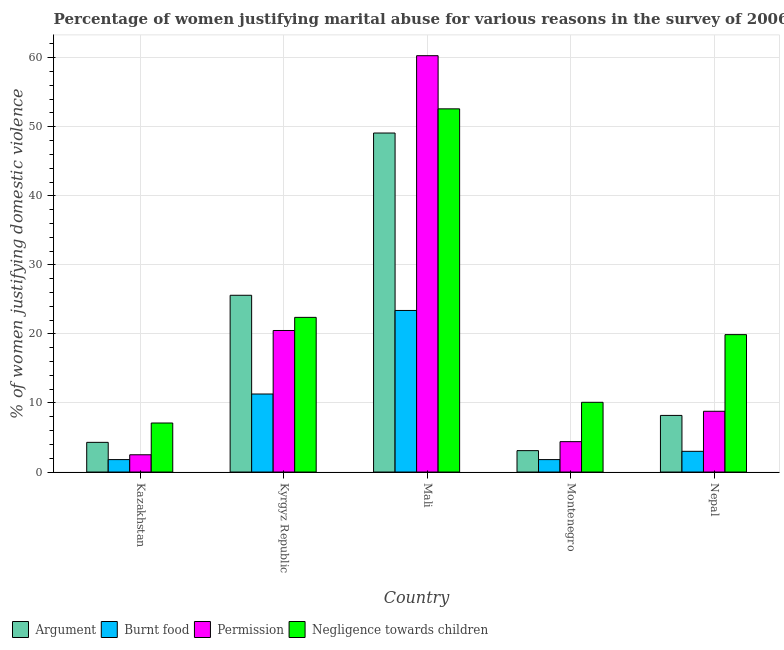How many groups of bars are there?
Give a very brief answer. 5. Are the number of bars per tick equal to the number of legend labels?
Keep it short and to the point. Yes. Are the number of bars on each tick of the X-axis equal?
Offer a terse response. Yes. What is the label of the 2nd group of bars from the left?
Make the answer very short. Kyrgyz Republic. What is the percentage of women justifying abuse for going without permission in Kyrgyz Republic?
Your answer should be compact. 20.5. Across all countries, what is the maximum percentage of women justifying abuse for burning food?
Offer a terse response. 23.4. Across all countries, what is the minimum percentage of women justifying abuse for showing negligence towards children?
Offer a very short reply. 7.1. In which country was the percentage of women justifying abuse for burning food maximum?
Offer a terse response. Mali. In which country was the percentage of women justifying abuse for burning food minimum?
Your response must be concise. Kazakhstan. What is the total percentage of women justifying abuse for showing negligence towards children in the graph?
Give a very brief answer. 112.1. What is the difference between the percentage of women justifying abuse for showing negligence towards children in Mali and that in Montenegro?
Offer a terse response. 42.5. What is the average percentage of women justifying abuse for burning food per country?
Make the answer very short. 8.26. What is the difference between the percentage of women justifying abuse for burning food and percentage of women justifying abuse in the case of an argument in Kazakhstan?
Ensure brevity in your answer.  -2.5. In how many countries, is the percentage of women justifying abuse in the case of an argument greater than 58 %?
Provide a succinct answer. 0. What is the ratio of the percentage of women justifying abuse for going without permission in Kyrgyz Republic to that in Nepal?
Make the answer very short. 2.33. Is the difference between the percentage of women justifying abuse for burning food in Kazakhstan and Mali greater than the difference between the percentage of women justifying abuse for going without permission in Kazakhstan and Mali?
Keep it short and to the point. Yes. What is the difference between the highest and the second highest percentage of women justifying abuse for going without permission?
Provide a short and direct response. 39.8. What is the difference between the highest and the lowest percentage of women justifying abuse for going without permission?
Your answer should be compact. 57.8. In how many countries, is the percentage of women justifying abuse for showing negligence towards children greater than the average percentage of women justifying abuse for showing negligence towards children taken over all countries?
Provide a short and direct response. 1. Is the sum of the percentage of women justifying abuse for going without permission in Kazakhstan and Kyrgyz Republic greater than the maximum percentage of women justifying abuse in the case of an argument across all countries?
Make the answer very short. No. Is it the case that in every country, the sum of the percentage of women justifying abuse in the case of an argument and percentage of women justifying abuse for going without permission is greater than the sum of percentage of women justifying abuse for showing negligence towards children and percentage of women justifying abuse for burning food?
Provide a short and direct response. No. What does the 2nd bar from the left in Mali represents?
Your answer should be compact. Burnt food. What does the 1st bar from the right in Montenegro represents?
Your response must be concise. Negligence towards children. Is it the case that in every country, the sum of the percentage of women justifying abuse in the case of an argument and percentage of women justifying abuse for burning food is greater than the percentage of women justifying abuse for going without permission?
Give a very brief answer. Yes. How many bars are there?
Your answer should be compact. 20. What is the difference between two consecutive major ticks on the Y-axis?
Ensure brevity in your answer.  10. How are the legend labels stacked?
Provide a short and direct response. Horizontal. What is the title of the graph?
Ensure brevity in your answer.  Percentage of women justifying marital abuse for various reasons in the survey of 2006. Does "Rule based governance" appear as one of the legend labels in the graph?
Offer a very short reply. No. What is the label or title of the Y-axis?
Provide a succinct answer. % of women justifying domestic violence. What is the % of women justifying domestic violence in Argument in Kazakhstan?
Give a very brief answer. 4.3. What is the % of women justifying domestic violence in Permission in Kazakhstan?
Make the answer very short. 2.5. What is the % of women justifying domestic violence in Argument in Kyrgyz Republic?
Provide a short and direct response. 25.6. What is the % of women justifying domestic violence of Burnt food in Kyrgyz Republic?
Provide a succinct answer. 11.3. What is the % of women justifying domestic violence of Negligence towards children in Kyrgyz Republic?
Provide a succinct answer. 22.4. What is the % of women justifying domestic violence in Argument in Mali?
Offer a very short reply. 49.1. What is the % of women justifying domestic violence in Burnt food in Mali?
Ensure brevity in your answer.  23.4. What is the % of women justifying domestic violence of Permission in Mali?
Provide a succinct answer. 60.3. What is the % of women justifying domestic violence of Negligence towards children in Mali?
Your response must be concise. 52.6. What is the % of women justifying domestic violence in Permission in Montenegro?
Your response must be concise. 4.4. What is the % of women justifying domestic violence of Negligence towards children in Montenegro?
Offer a terse response. 10.1. What is the % of women justifying domestic violence of Argument in Nepal?
Your answer should be very brief. 8.2. What is the % of women justifying domestic violence of Permission in Nepal?
Your answer should be very brief. 8.8. What is the % of women justifying domestic violence of Negligence towards children in Nepal?
Your answer should be compact. 19.9. Across all countries, what is the maximum % of women justifying domestic violence in Argument?
Your response must be concise. 49.1. Across all countries, what is the maximum % of women justifying domestic violence of Burnt food?
Your response must be concise. 23.4. Across all countries, what is the maximum % of women justifying domestic violence of Permission?
Make the answer very short. 60.3. Across all countries, what is the maximum % of women justifying domestic violence of Negligence towards children?
Provide a succinct answer. 52.6. Across all countries, what is the minimum % of women justifying domestic violence of Burnt food?
Offer a terse response. 1.8. What is the total % of women justifying domestic violence of Argument in the graph?
Provide a succinct answer. 90.3. What is the total % of women justifying domestic violence of Burnt food in the graph?
Your response must be concise. 41.3. What is the total % of women justifying domestic violence in Permission in the graph?
Give a very brief answer. 96.5. What is the total % of women justifying domestic violence in Negligence towards children in the graph?
Your answer should be compact. 112.1. What is the difference between the % of women justifying domestic violence of Argument in Kazakhstan and that in Kyrgyz Republic?
Provide a short and direct response. -21.3. What is the difference between the % of women justifying domestic violence of Burnt food in Kazakhstan and that in Kyrgyz Republic?
Offer a terse response. -9.5. What is the difference between the % of women justifying domestic violence of Permission in Kazakhstan and that in Kyrgyz Republic?
Keep it short and to the point. -18. What is the difference between the % of women justifying domestic violence in Negligence towards children in Kazakhstan and that in Kyrgyz Republic?
Give a very brief answer. -15.3. What is the difference between the % of women justifying domestic violence in Argument in Kazakhstan and that in Mali?
Your response must be concise. -44.8. What is the difference between the % of women justifying domestic violence in Burnt food in Kazakhstan and that in Mali?
Give a very brief answer. -21.6. What is the difference between the % of women justifying domestic violence in Permission in Kazakhstan and that in Mali?
Ensure brevity in your answer.  -57.8. What is the difference between the % of women justifying domestic violence in Negligence towards children in Kazakhstan and that in Mali?
Offer a very short reply. -45.5. What is the difference between the % of women justifying domestic violence of Burnt food in Kazakhstan and that in Montenegro?
Ensure brevity in your answer.  0. What is the difference between the % of women justifying domestic violence in Argument in Kazakhstan and that in Nepal?
Make the answer very short. -3.9. What is the difference between the % of women justifying domestic violence in Permission in Kazakhstan and that in Nepal?
Your answer should be very brief. -6.3. What is the difference between the % of women justifying domestic violence of Negligence towards children in Kazakhstan and that in Nepal?
Give a very brief answer. -12.8. What is the difference between the % of women justifying domestic violence in Argument in Kyrgyz Republic and that in Mali?
Give a very brief answer. -23.5. What is the difference between the % of women justifying domestic violence in Permission in Kyrgyz Republic and that in Mali?
Your answer should be very brief. -39.8. What is the difference between the % of women justifying domestic violence in Negligence towards children in Kyrgyz Republic and that in Mali?
Offer a terse response. -30.2. What is the difference between the % of women justifying domestic violence in Negligence towards children in Kyrgyz Republic and that in Montenegro?
Provide a short and direct response. 12.3. What is the difference between the % of women justifying domestic violence in Argument in Kyrgyz Republic and that in Nepal?
Make the answer very short. 17.4. What is the difference between the % of women justifying domestic violence of Burnt food in Kyrgyz Republic and that in Nepal?
Keep it short and to the point. 8.3. What is the difference between the % of women justifying domestic violence in Permission in Kyrgyz Republic and that in Nepal?
Your answer should be compact. 11.7. What is the difference between the % of women justifying domestic violence in Argument in Mali and that in Montenegro?
Make the answer very short. 46. What is the difference between the % of women justifying domestic violence in Burnt food in Mali and that in Montenegro?
Make the answer very short. 21.6. What is the difference between the % of women justifying domestic violence of Permission in Mali and that in Montenegro?
Your response must be concise. 55.9. What is the difference between the % of women justifying domestic violence of Negligence towards children in Mali and that in Montenegro?
Keep it short and to the point. 42.5. What is the difference between the % of women justifying domestic violence of Argument in Mali and that in Nepal?
Your response must be concise. 40.9. What is the difference between the % of women justifying domestic violence of Burnt food in Mali and that in Nepal?
Make the answer very short. 20.4. What is the difference between the % of women justifying domestic violence in Permission in Mali and that in Nepal?
Make the answer very short. 51.5. What is the difference between the % of women justifying domestic violence of Negligence towards children in Mali and that in Nepal?
Your answer should be compact. 32.7. What is the difference between the % of women justifying domestic violence in Burnt food in Montenegro and that in Nepal?
Give a very brief answer. -1.2. What is the difference between the % of women justifying domestic violence of Argument in Kazakhstan and the % of women justifying domestic violence of Permission in Kyrgyz Republic?
Your response must be concise. -16.2. What is the difference between the % of women justifying domestic violence of Argument in Kazakhstan and the % of women justifying domestic violence of Negligence towards children in Kyrgyz Republic?
Offer a very short reply. -18.1. What is the difference between the % of women justifying domestic violence in Burnt food in Kazakhstan and the % of women justifying domestic violence in Permission in Kyrgyz Republic?
Give a very brief answer. -18.7. What is the difference between the % of women justifying domestic violence of Burnt food in Kazakhstan and the % of women justifying domestic violence of Negligence towards children in Kyrgyz Republic?
Your answer should be very brief. -20.6. What is the difference between the % of women justifying domestic violence in Permission in Kazakhstan and the % of women justifying domestic violence in Negligence towards children in Kyrgyz Republic?
Keep it short and to the point. -19.9. What is the difference between the % of women justifying domestic violence in Argument in Kazakhstan and the % of women justifying domestic violence in Burnt food in Mali?
Make the answer very short. -19.1. What is the difference between the % of women justifying domestic violence in Argument in Kazakhstan and the % of women justifying domestic violence in Permission in Mali?
Provide a short and direct response. -56. What is the difference between the % of women justifying domestic violence in Argument in Kazakhstan and the % of women justifying domestic violence in Negligence towards children in Mali?
Keep it short and to the point. -48.3. What is the difference between the % of women justifying domestic violence of Burnt food in Kazakhstan and the % of women justifying domestic violence of Permission in Mali?
Provide a succinct answer. -58.5. What is the difference between the % of women justifying domestic violence in Burnt food in Kazakhstan and the % of women justifying domestic violence in Negligence towards children in Mali?
Your response must be concise. -50.8. What is the difference between the % of women justifying domestic violence in Permission in Kazakhstan and the % of women justifying domestic violence in Negligence towards children in Mali?
Your response must be concise. -50.1. What is the difference between the % of women justifying domestic violence of Argument in Kazakhstan and the % of women justifying domestic violence of Burnt food in Montenegro?
Provide a succinct answer. 2.5. What is the difference between the % of women justifying domestic violence in Argument in Kazakhstan and the % of women justifying domestic violence in Permission in Montenegro?
Provide a succinct answer. -0.1. What is the difference between the % of women justifying domestic violence in Burnt food in Kazakhstan and the % of women justifying domestic violence in Negligence towards children in Montenegro?
Provide a succinct answer. -8.3. What is the difference between the % of women justifying domestic violence in Argument in Kazakhstan and the % of women justifying domestic violence in Burnt food in Nepal?
Offer a terse response. 1.3. What is the difference between the % of women justifying domestic violence in Argument in Kazakhstan and the % of women justifying domestic violence in Permission in Nepal?
Your answer should be compact. -4.5. What is the difference between the % of women justifying domestic violence of Argument in Kazakhstan and the % of women justifying domestic violence of Negligence towards children in Nepal?
Provide a succinct answer. -15.6. What is the difference between the % of women justifying domestic violence of Burnt food in Kazakhstan and the % of women justifying domestic violence of Negligence towards children in Nepal?
Make the answer very short. -18.1. What is the difference between the % of women justifying domestic violence of Permission in Kazakhstan and the % of women justifying domestic violence of Negligence towards children in Nepal?
Ensure brevity in your answer.  -17.4. What is the difference between the % of women justifying domestic violence of Argument in Kyrgyz Republic and the % of women justifying domestic violence of Permission in Mali?
Give a very brief answer. -34.7. What is the difference between the % of women justifying domestic violence of Argument in Kyrgyz Republic and the % of women justifying domestic violence of Negligence towards children in Mali?
Make the answer very short. -27. What is the difference between the % of women justifying domestic violence in Burnt food in Kyrgyz Republic and the % of women justifying domestic violence in Permission in Mali?
Your response must be concise. -49. What is the difference between the % of women justifying domestic violence in Burnt food in Kyrgyz Republic and the % of women justifying domestic violence in Negligence towards children in Mali?
Provide a succinct answer. -41.3. What is the difference between the % of women justifying domestic violence in Permission in Kyrgyz Republic and the % of women justifying domestic violence in Negligence towards children in Mali?
Your response must be concise. -32.1. What is the difference between the % of women justifying domestic violence in Argument in Kyrgyz Republic and the % of women justifying domestic violence in Burnt food in Montenegro?
Make the answer very short. 23.8. What is the difference between the % of women justifying domestic violence of Argument in Kyrgyz Republic and the % of women justifying domestic violence of Permission in Montenegro?
Ensure brevity in your answer.  21.2. What is the difference between the % of women justifying domestic violence of Burnt food in Kyrgyz Republic and the % of women justifying domestic violence of Negligence towards children in Montenegro?
Give a very brief answer. 1.2. What is the difference between the % of women justifying domestic violence in Permission in Kyrgyz Republic and the % of women justifying domestic violence in Negligence towards children in Montenegro?
Your answer should be very brief. 10.4. What is the difference between the % of women justifying domestic violence in Argument in Kyrgyz Republic and the % of women justifying domestic violence in Burnt food in Nepal?
Offer a terse response. 22.6. What is the difference between the % of women justifying domestic violence of Burnt food in Kyrgyz Republic and the % of women justifying domestic violence of Negligence towards children in Nepal?
Make the answer very short. -8.6. What is the difference between the % of women justifying domestic violence of Permission in Kyrgyz Republic and the % of women justifying domestic violence of Negligence towards children in Nepal?
Offer a terse response. 0.6. What is the difference between the % of women justifying domestic violence in Argument in Mali and the % of women justifying domestic violence in Burnt food in Montenegro?
Ensure brevity in your answer.  47.3. What is the difference between the % of women justifying domestic violence in Argument in Mali and the % of women justifying domestic violence in Permission in Montenegro?
Offer a terse response. 44.7. What is the difference between the % of women justifying domestic violence of Argument in Mali and the % of women justifying domestic violence of Negligence towards children in Montenegro?
Your answer should be very brief. 39. What is the difference between the % of women justifying domestic violence in Burnt food in Mali and the % of women justifying domestic violence in Permission in Montenegro?
Offer a terse response. 19. What is the difference between the % of women justifying domestic violence in Burnt food in Mali and the % of women justifying domestic violence in Negligence towards children in Montenegro?
Provide a succinct answer. 13.3. What is the difference between the % of women justifying domestic violence in Permission in Mali and the % of women justifying domestic violence in Negligence towards children in Montenegro?
Give a very brief answer. 50.2. What is the difference between the % of women justifying domestic violence in Argument in Mali and the % of women justifying domestic violence in Burnt food in Nepal?
Your answer should be very brief. 46.1. What is the difference between the % of women justifying domestic violence of Argument in Mali and the % of women justifying domestic violence of Permission in Nepal?
Make the answer very short. 40.3. What is the difference between the % of women justifying domestic violence of Argument in Mali and the % of women justifying domestic violence of Negligence towards children in Nepal?
Keep it short and to the point. 29.2. What is the difference between the % of women justifying domestic violence of Burnt food in Mali and the % of women justifying domestic violence of Permission in Nepal?
Ensure brevity in your answer.  14.6. What is the difference between the % of women justifying domestic violence of Burnt food in Mali and the % of women justifying domestic violence of Negligence towards children in Nepal?
Offer a very short reply. 3.5. What is the difference between the % of women justifying domestic violence of Permission in Mali and the % of women justifying domestic violence of Negligence towards children in Nepal?
Keep it short and to the point. 40.4. What is the difference between the % of women justifying domestic violence of Argument in Montenegro and the % of women justifying domestic violence of Permission in Nepal?
Your response must be concise. -5.7. What is the difference between the % of women justifying domestic violence of Argument in Montenegro and the % of women justifying domestic violence of Negligence towards children in Nepal?
Give a very brief answer. -16.8. What is the difference between the % of women justifying domestic violence in Burnt food in Montenegro and the % of women justifying domestic violence in Negligence towards children in Nepal?
Your answer should be compact. -18.1. What is the difference between the % of women justifying domestic violence of Permission in Montenegro and the % of women justifying domestic violence of Negligence towards children in Nepal?
Keep it short and to the point. -15.5. What is the average % of women justifying domestic violence in Argument per country?
Keep it short and to the point. 18.06. What is the average % of women justifying domestic violence of Burnt food per country?
Keep it short and to the point. 8.26. What is the average % of women justifying domestic violence of Permission per country?
Offer a very short reply. 19.3. What is the average % of women justifying domestic violence of Negligence towards children per country?
Offer a very short reply. 22.42. What is the difference between the % of women justifying domestic violence of Burnt food and % of women justifying domestic violence of Permission in Kazakhstan?
Offer a terse response. -0.7. What is the difference between the % of women justifying domestic violence in Burnt food and % of women justifying domestic violence in Negligence towards children in Kazakhstan?
Give a very brief answer. -5.3. What is the difference between the % of women justifying domestic violence of Permission and % of women justifying domestic violence of Negligence towards children in Kazakhstan?
Keep it short and to the point. -4.6. What is the difference between the % of women justifying domestic violence in Argument and % of women justifying domestic violence in Burnt food in Kyrgyz Republic?
Provide a short and direct response. 14.3. What is the difference between the % of women justifying domestic violence in Argument and % of women justifying domestic violence in Permission in Kyrgyz Republic?
Ensure brevity in your answer.  5.1. What is the difference between the % of women justifying domestic violence in Burnt food and % of women justifying domestic violence in Permission in Kyrgyz Republic?
Offer a very short reply. -9.2. What is the difference between the % of women justifying domestic violence in Burnt food and % of women justifying domestic violence in Negligence towards children in Kyrgyz Republic?
Give a very brief answer. -11.1. What is the difference between the % of women justifying domestic violence in Argument and % of women justifying domestic violence in Burnt food in Mali?
Your response must be concise. 25.7. What is the difference between the % of women justifying domestic violence in Argument and % of women justifying domestic violence in Negligence towards children in Mali?
Your answer should be compact. -3.5. What is the difference between the % of women justifying domestic violence of Burnt food and % of women justifying domestic violence of Permission in Mali?
Offer a terse response. -36.9. What is the difference between the % of women justifying domestic violence in Burnt food and % of women justifying domestic violence in Negligence towards children in Mali?
Provide a short and direct response. -29.2. What is the difference between the % of women justifying domestic violence of Permission and % of women justifying domestic violence of Negligence towards children in Mali?
Give a very brief answer. 7.7. What is the difference between the % of women justifying domestic violence in Argument and % of women justifying domestic violence in Negligence towards children in Montenegro?
Give a very brief answer. -7. What is the difference between the % of women justifying domestic violence of Burnt food and % of women justifying domestic violence of Permission in Montenegro?
Ensure brevity in your answer.  -2.6. What is the difference between the % of women justifying domestic violence of Argument and % of women justifying domestic violence of Negligence towards children in Nepal?
Your response must be concise. -11.7. What is the difference between the % of women justifying domestic violence of Burnt food and % of women justifying domestic violence of Permission in Nepal?
Your response must be concise. -5.8. What is the difference between the % of women justifying domestic violence of Burnt food and % of women justifying domestic violence of Negligence towards children in Nepal?
Your answer should be compact. -16.9. What is the difference between the % of women justifying domestic violence of Permission and % of women justifying domestic violence of Negligence towards children in Nepal?
Offer a terse response. -11.1. What is the ratio of the % of women justifying domestic violence of Argument in Kazakhstan to that in Kyrgyz Republic?
Your response must be concise. 0.17. What is the ratio of the % of women justifying domestic violence in Burnt food in Kazakhstan to that in Kyrgyz Republic?
Your answer should be very brief. 0.16. What is the ratio of the % of women justifying domestic violence in Permission in Kazakhstan to that in Kyrgyz Republic?
Provide a short and direct response. 0.12. What is the ratio of the % of women justifying domestic violence in Negligence towards children in Kazakhstan to that in Kyrgyz Republic?
Your response must be concise. 0.32. What is the ratio of the % of women justifying domestic violence in Argument in Kazakhstan to that in Mali?
Offer a very short reply. 0.09. What is the ratio of the % of women justifying domestic violence of Burnt food in Kazakhstan to that in Mali?
Your answer should be compact. 0.08. What is the ratio of the % of women justifying domestic violence in Permission in Kazakhstan to that in Mali?
Ensure brevity in your answer.  0.04. What is the ratio of the % of women justifying domestic violence of Negligence towards children in Kazakhstan to that in Mali?
Make the answer very short. 0.14. What is the ratio of the % of women justifying domestic violence of Argument in Kazakhstan to that in Montenegro?
Your answer should be very brief. 1.39. What is the ratio of the % of women justifying domestic violence in Burnt food in Kazakhstan to that in Montenegro?
Offer a very short reply. 1. What is the ratio of the % of women justifying domestic violence of Permission in Kazakhstan to that in Montenegro?
Your answer should be compact. 0.57. What is the ratio of the % of women justifying domestic violence in Negligence towards children in Kazakhstan to that in Montenegro?
Keep it short and to the point. 0.7. What is the ratio of the % of women justifying domestic violence in Argument in Kazakhstan to that in Nepal?
Make the answer very short. 0.52. What is the ratio of the % of women justifying domestic violence in Burnt food in Kazakhstan to that in Nepal?
Your answer should be very brief. 0.6. What is the ratio of the % of women justifying domestic violence in Permission in Kazakhstan to that in Nepal?
Provide a short and direct response. 0.28. What is the ratio of the % of women justifying domestic violence of Negligence towards children in Kazakhstan to that in Nepal?
Ensure brevity in your answer.  0.36. What is the ratio of the % of women justifying domestic violence of Argument in Kyrgyz Republic to that in Mali?
Provide a short and direct response. 0.52. What is the ratio of the % of women justifying domestic violence of Burnt food in Kyrgyz Republic to that in Mali?
Provide a succinct answer. 0.48. What is the ratio of the % of women justifying domestic violence of Permission in Kyrgyz Republic to that in Mali?
Your answer should be compact. 0.34. What is the ratio of the % of women justifying domestic violence in Negligence towards children in Kyrgyz Republic to that in Mali?
Make the answer very short. 0.43. What is the ratio of the % of women justifying domestic violence of Argument in Kyrgyz Republic to that in Montenegro?
Keep it short and to the point. 8.26. What is the ratio of the % of women justifying domestic violence in Burnt food in Kyrgyz Republic to that in Montenegro?
Offer a very short reply. 6.28. What is the ratio of the % of women justifying domestic violence of Permission in Kyrgyz Republic to that in Montenegro?
Provide a short and direct response. 4.66. What is the ratio of the % of women justifying domestic violence in Negligence towards children in Kyrgyz Republic to that in Montenegro?
Give a very brief answer. 2.22. What is the ratio of the % of women justifying domestic violence in Argument in Kyrgyz Republic to that in Nepal?
Provide a short and direct response. 3.12. What is the ratio of the % of women justifying domestic violence of Burnt food in Kyrgyz Republic to that in Nepal?
Give a very brief answer. 3.77. What is the ratio of the % of women justifying domestic violence of Permission in Kyrgyz Republic to that in Nepal?
Your answer should be compact. 2.33. What is the ratio of the % of women justifying domestic violence of Negligence towards children in Kyrgyz Republic to that in Nepal?
Provide a succinct answer. 1.13. What is the ratio of the % of women justifying domestic violence of Argument in Mali to that in Montenegro?
Offer a terse response. 15.84. What is the ratio of the % of women justifying domestic violence in Permission in Mali to that in Montenegro?
Offer a very short reply. 13.7. What is the ratio of the % of women justifying domestic violence of Negligence towards children in Mali to that in Montenegro?
Offer a very short reply. 5.21. What is the ratio of the % of women justifying domestic violence in Argument in Mali to that in Nepal?
Offer a very short reply. 5.99. What is the ratio of the % of women justifying domestic violence in Burnt food in Mali to that in Nepal?
Offer a very short reply. 7.8. What is the ratio of the % of women justifying domestic violence of Permission in Mali to that in Nepal?
Your answer should be very brief. 6.85. What is the ratio of the % of women justifying domestic violence in Negligence towards children in Mali to that in Nepal?
Provide a succinct answer. 2.64. What is the ratio of the % of women justifying domestic violence in Argument in Montenegro to that in Nepal?
Make the answer very short. 0.38. What is the ratio of the % of women justifying domestic violence of Burnt food in Montenegro to that in Nepal?
Make the answer very short. 0.6. What is the ratio of the % of women justifying domestic violence of Negligence towards children in Montenegro to that in Nepal?
Make the answer very short. 0.51. What is the difference between the highest and the second highest % of women justifying domestic violence of Argument?
Provide a succinct answer. 23.5. What is the difference between the highest and the second highest % of women justifying domestic violence of Burnt food?
Offer a terse response. 12.1. What is the difference between the highest and the second highest % of women justifying domestic violence of Permission?
Your response must be concise. 39.8. What is the difference between the highest and the second highest % of women justifying domestic violence of Negligence towards children?
Keep it short and to the point. 30.2. What is the difference between the highest and the lowest % of women justifying domestic violence of Burnt food?
Offer a very short reply. 21.6. What is the difference between the highest and the lowest % of women justifying domestic violence of Permission?
Offer a very short reply. 57.8. What is the difference between the highest and the lowest % of women justifying domestic violence of Negligence towards children?
Offer a very short reply. 45.5. 